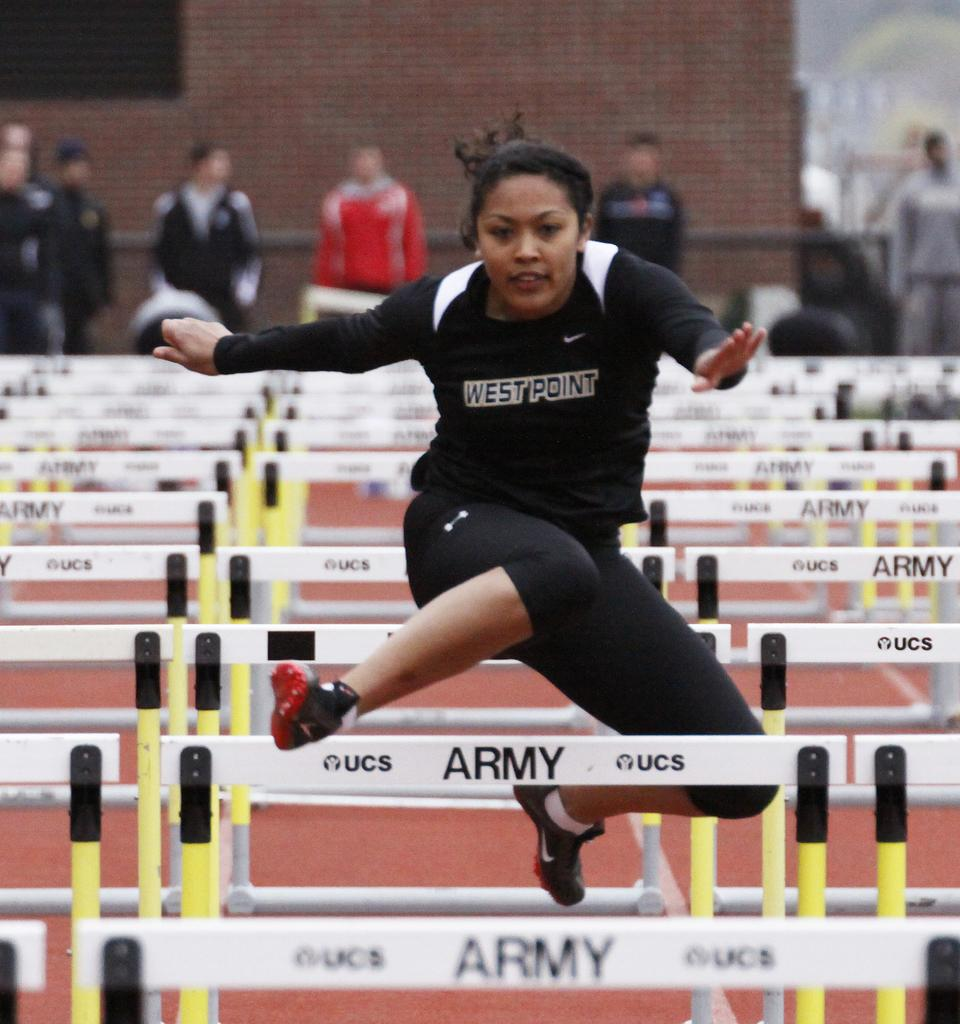Who is the main subject in the image? There is a lady in the image. What is the lady doing in the image? The lady is jumping hurdles. What can be seen in the background of the image? There is a brick wall in the background of the image. Are there any other people present in the image? Yes, there are people in the image. What type of harmony is being played by the lady while jumping hurdles? There is no indication of music or harmony in the image; the lady is simply jumping hurdles. 